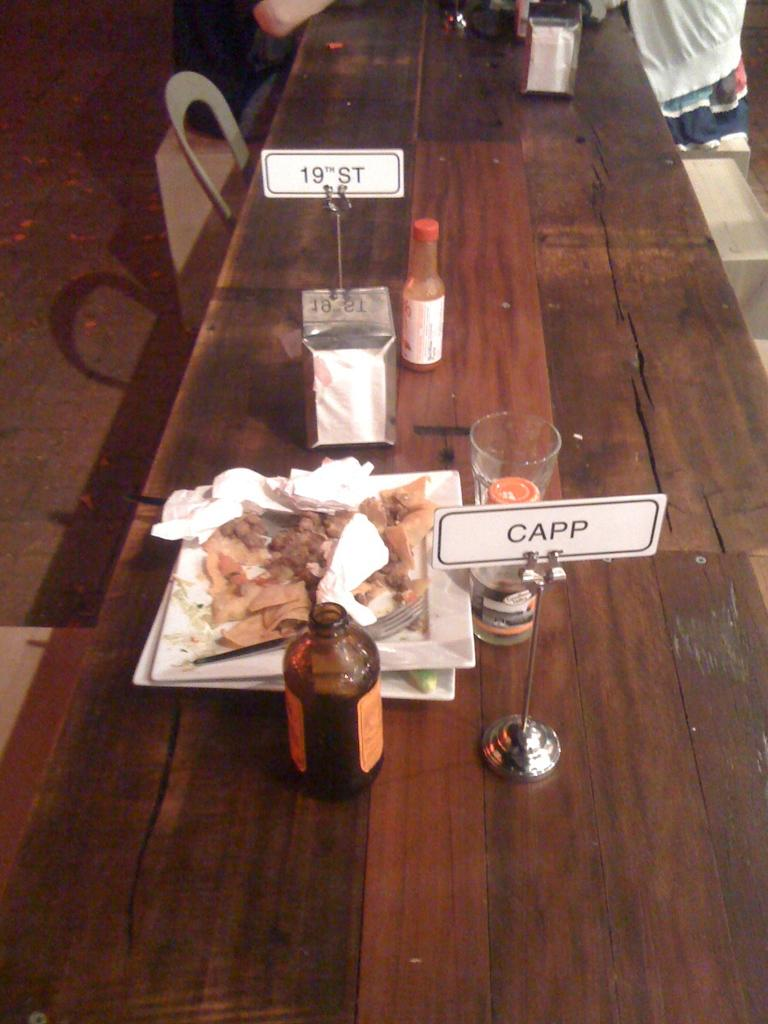<image>
Share a concise interpretation of the image provided. A plate of food on a table next to a sign that says Capp. 